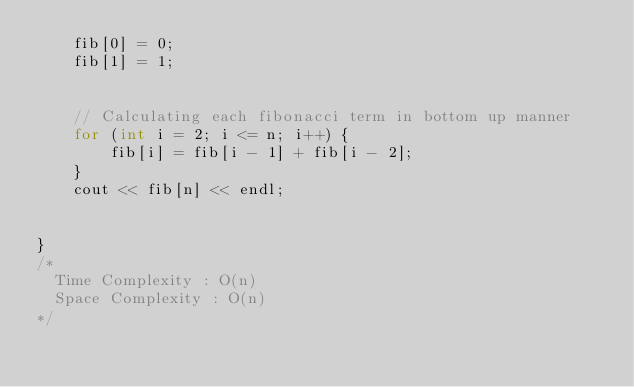Convert code to text. <code><loc_0><loc_0><loc_500><loc_500><_C++_>    fib[0] = 0;
    fib[1] = 1;


    // Calculating each fibonacci term in bottom up manner
    for (int i = 2; i <= n; i++) {
        fib[i] = fib[i - 1] + fib[i - 2];
    }
    cout << fib[n] << endl;


}
/*
  Time Complexity : O(n)
  Space Complexity : O(n)
*/</code> 